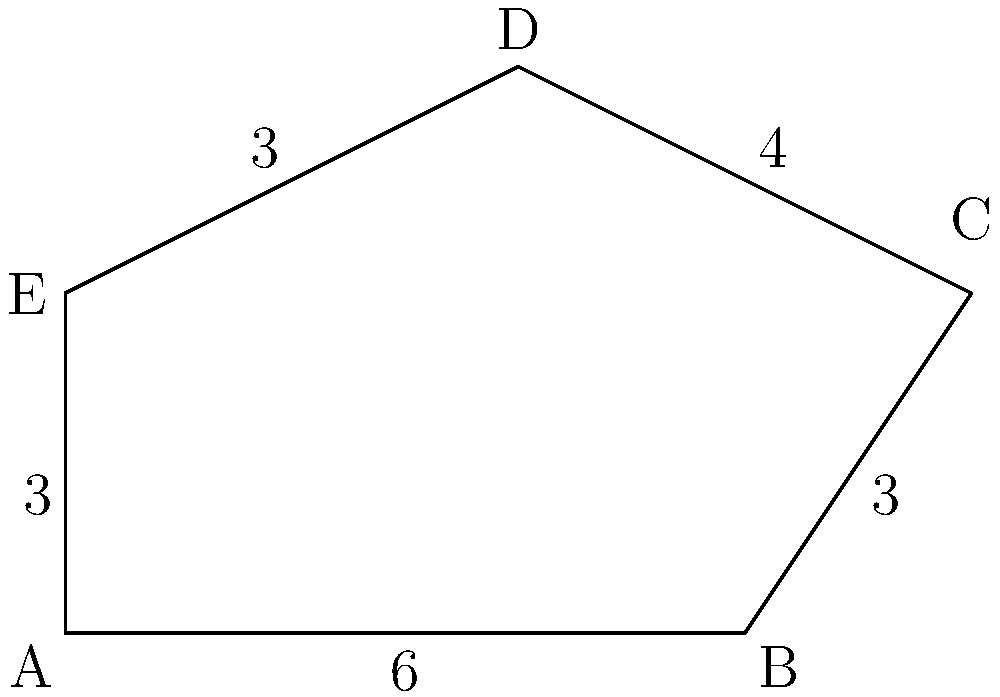For the VIP section at Rob Thomas's concert in Atlanta, you've designed an irregularly shaped area as shown in the diagram. The side lengths are given in meters. What is the perimeter of this VIP section? To calculate the perimeter of the irregularly shaped VIP section, we need to sum up all the side lengths:

1. Side AB = 6 meters
2. Side BC = 3 meters
3. Side CD = 4 meters
4. Side DE = 3 meters
5. Side EA = 3 meters

Now, let's add all these lengths:

$$\text{Perimeter} = AB + BC + CD + DE + EA$$
$$\text{Perimeter} = 6 + 3 + 4 + 3 + 3$$
$$\text{Perimeter} = 19 \text{ meters}$$

Therefore, the perimeter of the VIP section is 19 meters.
Answer: 19 meters 